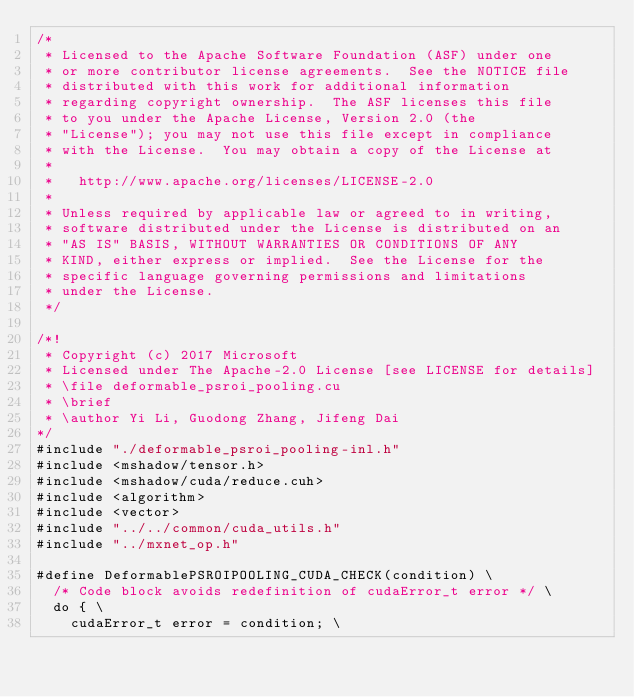<code> <loc_0><loc_0><loc_500><loc_500><_Cuda_>/*
 * Licensed to the Apache Software Foundation (ASF) under one
 * or more contributor license agreements.  See the NOTICE file
 * distributed with this work for additional information
 * regarding copyright ownership.  The ASF licenses this file
 * to you under the Apache License, Version 2.0 (the
 * "License"); you may not use this file except in compliance
 * with the License.  You may obtain a copy of the License at
 *
 *   http://www.apache.org/licenses/LICENSE-2.0
 *
 * Unless required by applicable law or agreed to in writing,
 * software distributed under the License is distributed on an
 * "AS IS" BASIS, WITHOUT WARRANTIES OR CONDITIONS OF ANY
 * KIND, either express or implied.  See the License for the
 * specific language governing permissions and limitations
 * under the License.
 */

/*!
 * Copyright (c) 2017 Microsoft
 * Licensed under The Apache-2.0 License [see LICENSE for details]
 * \file deformable_psroi_pooling.cu
 * \brief
 * \author Yi Li, Guodong Zhang, Jifeng Dai
*/
#include "./deformable_psroi_pooling-inl.h"
#include <mshadow/tensor.h>
#include <mshadow/cuda/reduce.cuh>
#include <algorithm>
#include <vector>
#include "../../common/cuda_utils.h"
#include "../mxnet_op.h"

#define DeformablePSROIPOOLING_CUDA_CHECK(condition) \
  /* Code block avoids redefinition of cudaError_t error */ \
  do { \
    cudaError_t error = condition; \</code> 